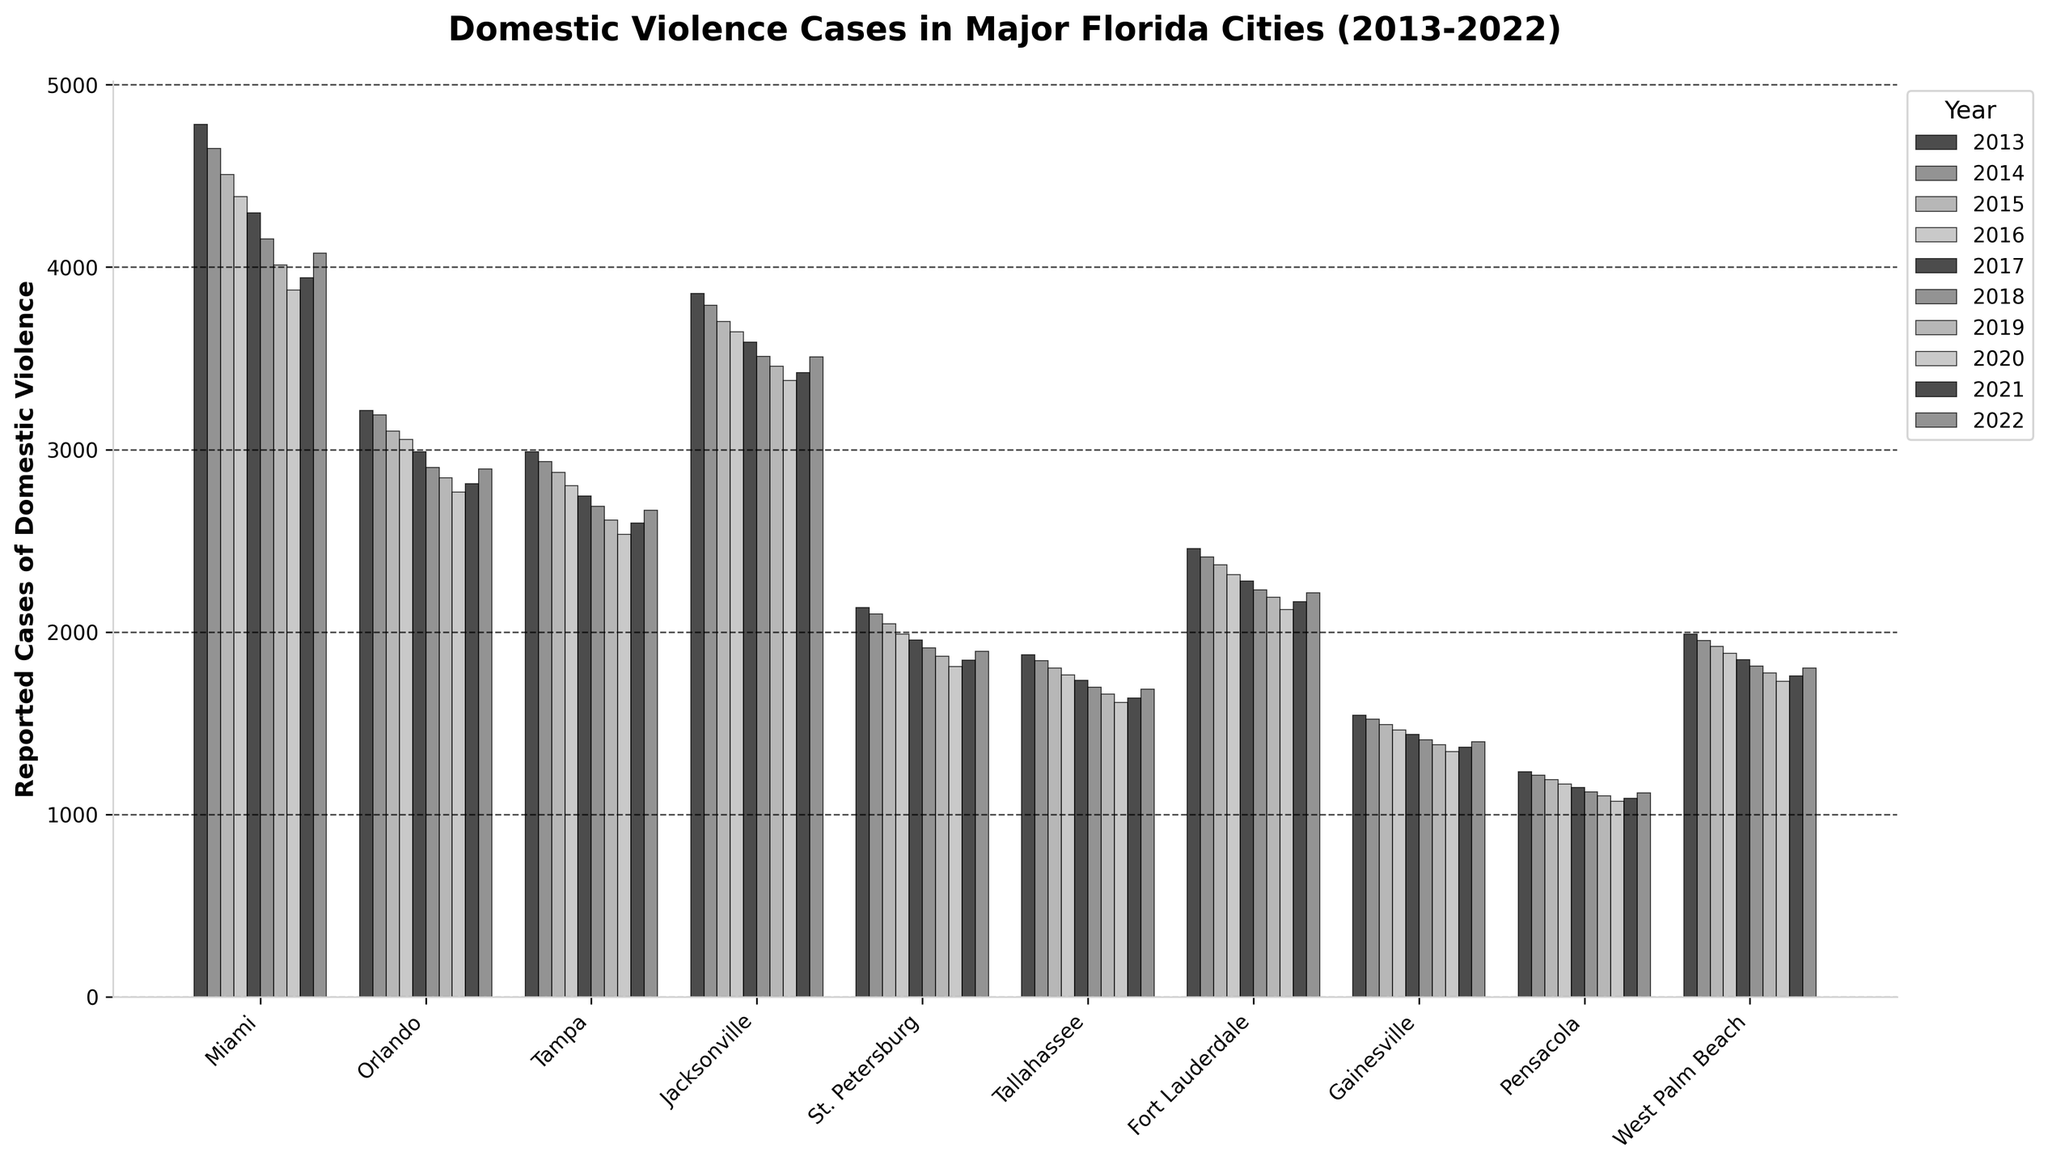Which city reported the highest number of domestic violence cases in 2013? Look at the 2013 bars for all cities and identify the tallest bar. Miami has the highest bar in 2013.
Answer: Miami Which city had the largest decline in reported domestic violence cases from 2013 to 2022? Subtract the 2022 value from the 2013 value for each city, then compare the differences. Miami's decline is the largest: 4782 - 4078 = 704.
Answer: Miami Which city had the smallest year-to-year fluctuation in reported domestic violence cases from 2013 to 2022? Observe which city's bars are the most consistent in height throughout the years. Pensacola shows the least fluctuation.
Answer: Pensacola How did the reported cases in Orlando compare to those in Tampa in 2022? Compare the heights of the bars for Orlando and Tampa in 2022. The bar for Orlando is taller than Tampa's in 2022.
Answer: Orlando had more What is the average number of reported cases in Gainesville over the decade? Add the cases from 2013 to 2022 for Gainesville and divide by 10: (1543 + 1521 + 1492 + 1463 + 1437 + 1409 + 1382 + 1345 + 1369 + 1398) / 10 = 1436.9.
Answer: 1437 (rounded) Which city had the highest reported cases in the final year shown, 2022? Identify the city with the tallest bar in the year 2022. Miami's bar is the tallest in 2022.
Answer: Miami Did any city show an increase in reported cases from 2021 to 2022? Compare the bars for 2021 and 2022 for each city. Miami shows an increase from 3942 to 4078.
Answer: Miami Out of Miami, Jacksonville, and Tampa, which city had the lowest report in 2018? Compare the bars for 2018 in Miami, Jacksonville, and Tampa. Tampa's bar is the lowest among the three cities.
Answer: Tampa Comparing Tallahassee and Fort Lauderdale, which city had fewer reported cases of domestic violence in every year? For each year, compare the heights of the bars for Tallahassee and Fort Lauderdale. Tallahassee had fewer cases than Fort Lauderdale each year.
Answer: Tallahassee What is the total number of reported cases across all cities in 2020? Sum the 2020 values for all cities: 3875 + 2768 + 2534 + 3378 + 1809 + 1612 + 2124 + 1345 + 1072 + 1729 = 22246.
Answer: 22246 